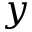Convert formula to latex. <formula><loc_0><loc_0><loc_500><loc_500>y</formula> 